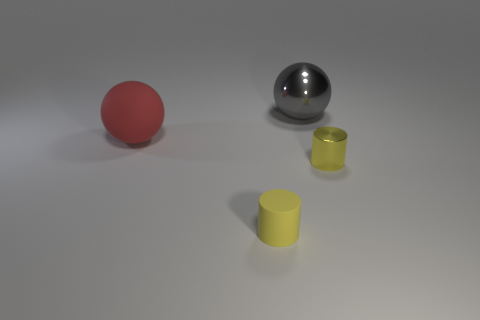Is the color of the large matte sphere the same as the shiny object in front of the red object?
Make the answer very short. No. Is the number of yellow cylinders less than the number of big blue spheres?
Provide a succinct answer. No. Are there more balls that are on the right side of the big rubber ball than things that are in front of the gray shiny thing?
Your response must be concise. No. Do the gray object and the red sphere have the same material?
Your answer should be very brief. No. What number of tiny yellow shiny objects are on the right side of the tiny yellow thing right of the gray thing?
Offer a terse response. 0. Does the rubber thing that is on the right side of the big red matte object have the same color as the big metal thing?
Give a very brief answer. No. What number of objects are either small purple shiny balls or spheres on the left side of the gray object?
Make the answer very short. 1. Does the big object that is left of the large metal object have the same shape as the metal thing that is behind the large matte ball?
Offer a very short reply. Yes. Is there anything else that is the same color as the rubber ball?
Ensure brevity in your answer.  No. There is a tiny yellow thing that is the same material as the gray ball; what shape is it?
Ensure brevity in your answer.  Cylinder. 